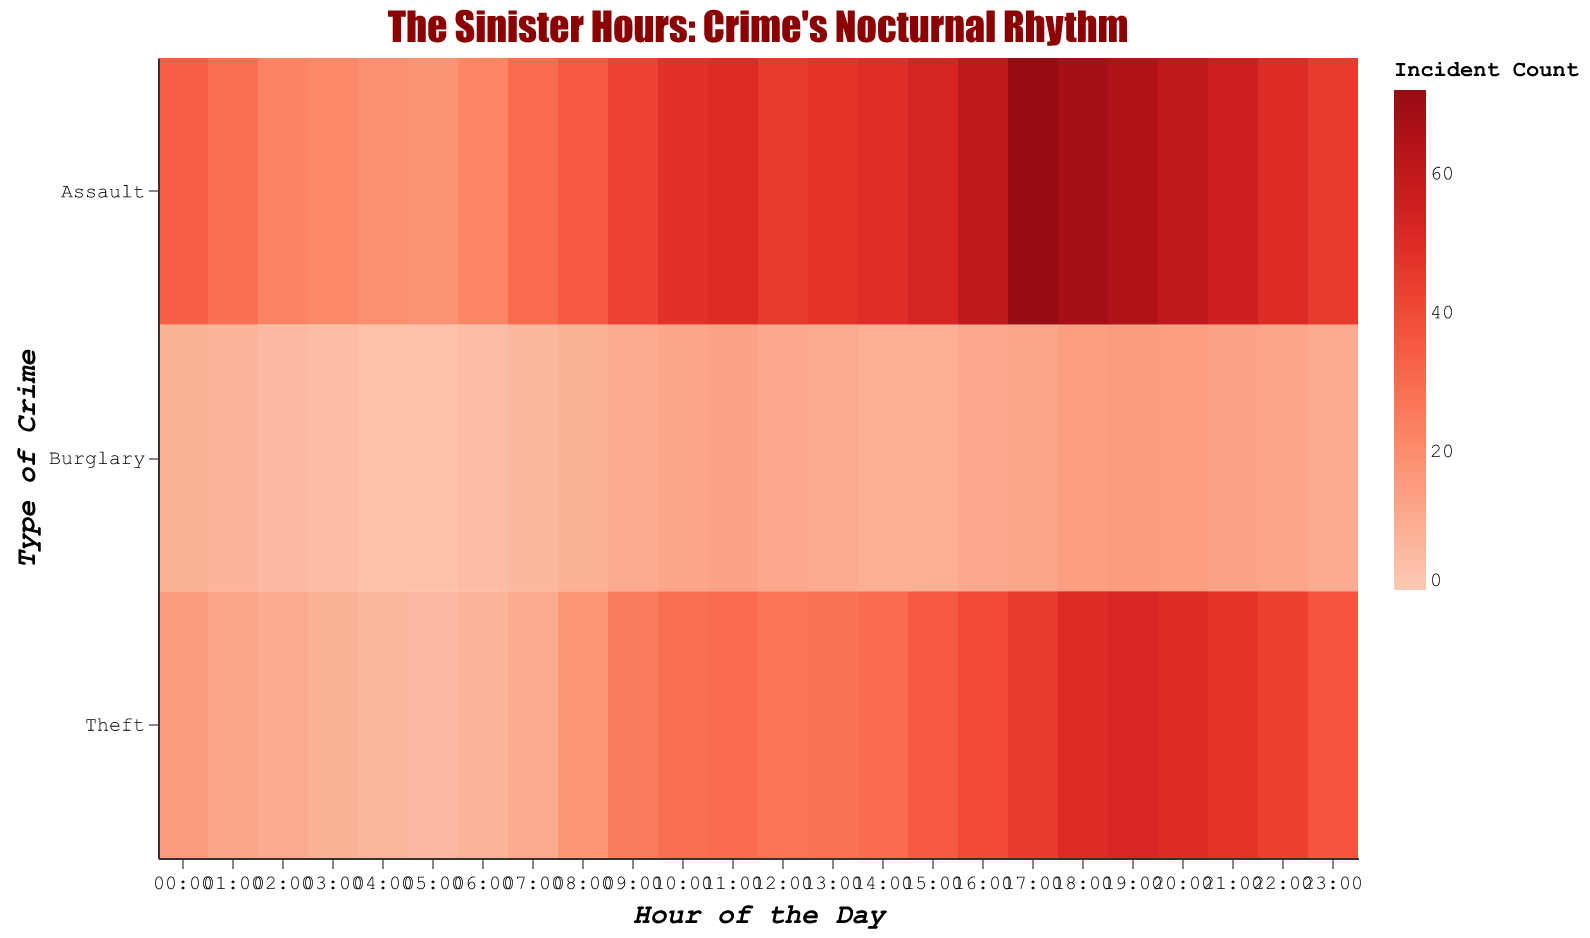What is the title of the heatmap? The title of the heatmap is usually located at the top center of the figure. Here, the title is "The Sinister Hours: Crime's Nocturnal Rhythm" as given in the code.
Answer: "The Sinister Hours: Crime's Nocturnal Rhythm" Which hour has the highest number of Assault incidents? To find the hour with the highest number of Assault incidents, look at the "Assault" row and identify the hour with the darkest red color, representing the highest count. According to the data, it is "17:00" with 72 incidents.
Answer: 17:00 During which hour is Burglary the lowest, and what is the count? To determine the hour with the lowest Burglary count, examine the "Burglary" row for the lightest color, representing the lowest count. The lowest count of 3 happens at the hours "04:00" and "05:00".
Answer: 04:00 and 05:00, 3 How does Theft count at 10:00 compare to that at 18:00? Check the "Theft" row for the hour "10:00" and note the count (29), then compare it with the count at "18:00" (50). The count at 18:00 is higher than at 10:00.
Answer: Higher at 18:00, 50 vs 29 What is the average Assault count between 20:00 and 23:00? To find the average Assault count between 20:00 and 23:00, sum the counts for "20:00" (60), "21:00" (55), "22:00" (50), and "23:00" (45), then divide by the number of hours (4). (60 + 55 + 50 + 45) / 4 = 52.5
Answer: 52.5 At what hour do all types of crimes (Assault, Burglary, Theft) have a spike compared to their respective previous hour? Look at the transitions hourly for each crime type. Identify the hour where all three counts increase compared to the previous hour. "17:00" shows all increasing from "16:00": Assault (60 to 72), Burglary (11 to 12), Theft (40 to 45).
Answer: 17:00 Which type of crime shows more consistent trends throughout the day, Assault, Burglary, or Theft? By observing the color gradient consistency in their rows, Burglary shows a comparatively consistent lighter gradient throughout, indicating smaller count variations, whereas Assault and Theft show more varied color intensities.
Answer: Burglary If a crime wave struck exactly at 12:00, which type of crime would likely be highest, and what is its count? Check the counts for hour "12:00" for all crimes: Assault (45), Burglary (11), Theft (27). The highest count at 12:00 is Assault with 45 incidents.
Answer: Assault, 45 What is the most common trend for Theft incidents from morning to night? Examine the "Theft" row across the hours—there's a general trend of increasing theft incidents from morning (06:00, 7) to peak in the late evening (18:00, 50).
Answer: Increasing trend 